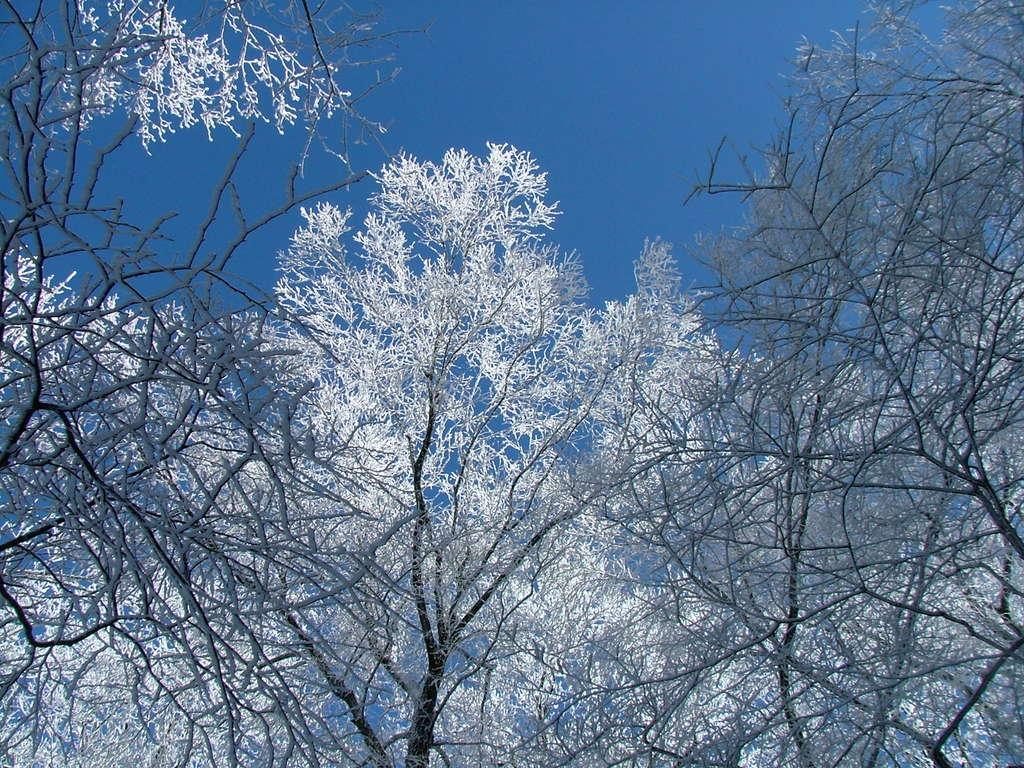What is the primary subject in the image? There are many trees in the image. What can be seen in the background of the image? The sky is visible in the background of the image. How does the clam react to the joke in the image? There is no clam or joke present in the image; it features trees and the sky. 